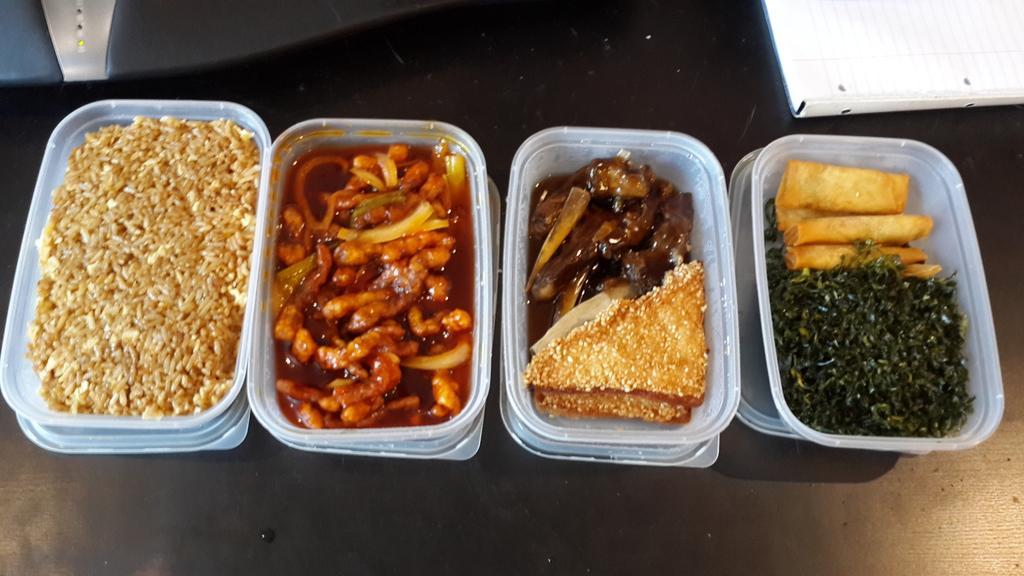Describe this image in one or two sentences. In the center of the image we can see four boxes containing food placed on the table. 